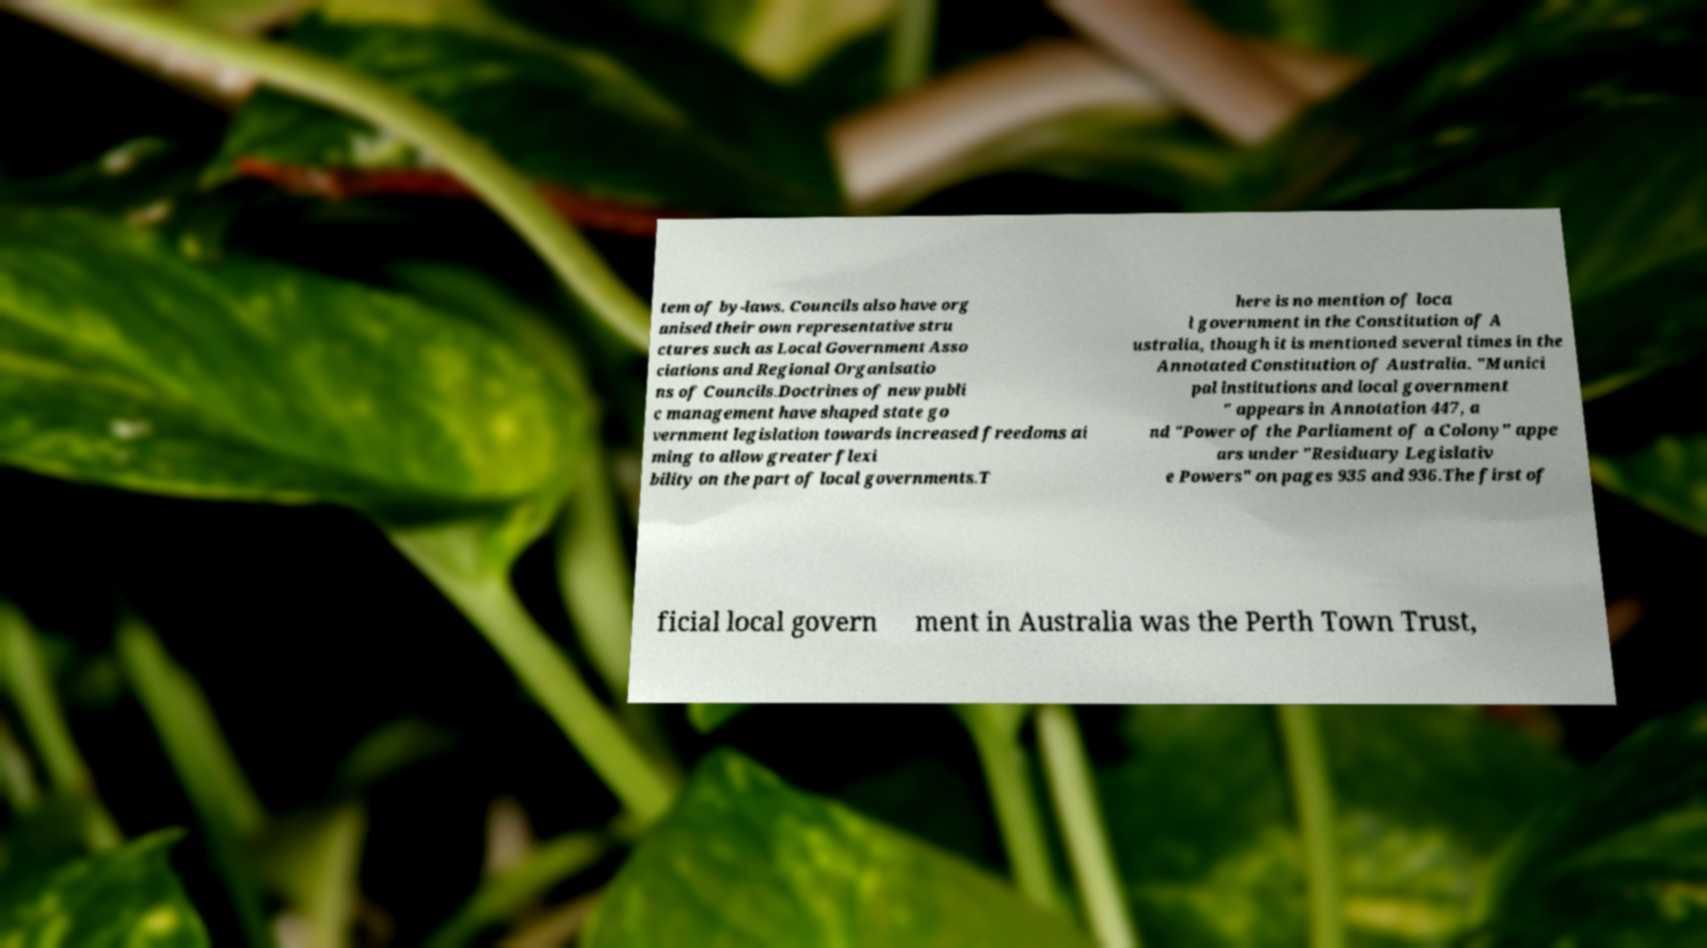Can you accurately transcribe the text from the provided image for me? tem of by-laws. Councils also have org anised their own representative stru ctures such as Local Government Asso ciations and Regional Organisatio ns of Councils.Doctrines of new publi c management have shaped state go vernment legislation towards increased freedoms ai ming to allow greater flexi bility on the part of local governments.T here is no mention of loca l government in the Constitution of A ustralia, though it is mentioned several times in the Annotated Constitution of Australia. "Munici pal institutions and local government " appears in Annotation 447, a nd "Power of the Parliament of a Colony" appe ars under "Residuary Legislativ e Powers" on pages 935 and 936.The first of ficial local govern ment in Australia was the Perth Town Trust, 